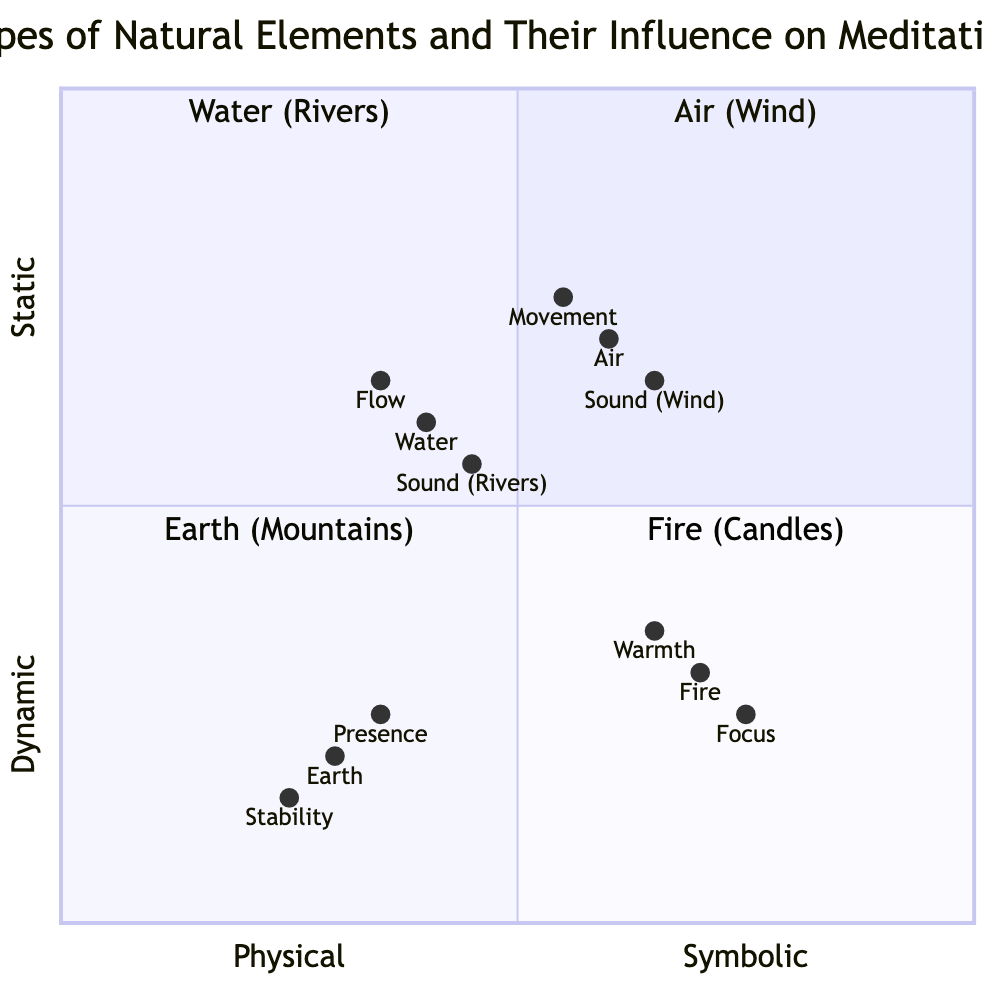What influence does "Water (Rivers)" have on meditation? According to the quadrant chart, "Water (Rivers)" influences meditation by calming the mind and reducing anxiety, creating a rhythmic focus point through sound, and symbolizes the flow of life and adaptability.
Answer: Calms the mind and reduces anxiety Which element symbolizes strength, stability, and stillness? In the chart, "Earth (Mountains)" is associated with strength, stability, and stillness, which is indicated in the symbolism provided in its quadrant.
Answer: Earth (Mountains) Compare the focus influences of "Air (Wind)" and "Fire (Candles)". "Air (Wind)" promotes movement and a sense of freedom, while "Fire (Candles)" offers a single point of concentration to aid in meditation. Here, "Fire (Candles)" provides a more direct focus compared to the freedom aspect of "Air (Wind)".
Answer: Fire (Candles) What is the position of "Air (Wind)" in terms of dynamism and symbolism? "Air (Wind)" is positioned towards the dynamic side with coordinates [0.6, 0.7], which indicates it is more dynamic compared to the other elements, emphasizing its flowing nature and symbolic representation of impermanence.
Answer: Dynamic How does the warmth of "Fire (Candles)" contribute to meditation? The warmth created by "Fire (Candles)" provides a comforting and inviting atmosphere for meditation, aligning with its influence on creating a serene environment that aids the meditative experience.
Answer: Creates a comforting atmosphere What is the significance of movement associated with "Air (Wind)"? The movement of "Air (Wind)" promotes a sense of freedom and the release of mental constraints, which aligns with the dynamic nature represented in its quadrant and emphasizes the connection with meditation.
Answer: Promotes freedom Which element has the lowest stability score? Referring to the chart’s stability values, "Earth (Mountains)" has the lowest stability score of 0.15, indicating it is perceived as the least stable in the context of the other elements in terms of meditation influence.
Answer: 0.15 Which element has the highest focus value? Within the values presented in the chart, "Fire (Candles)" has the highest focus value of 0.75, emphasizing its role in meditation as a pivotal point of concentration.
Answer: 0.75 Does "Water (Rivers)" or "Air (Wind)" have a higher sound influence score? Checking the scores, "Water (Rivers)" has a sound influence score of 0.55, while "Air (Wind)" has a sound score of 0.65, thus indicating that "Air (Wind)" has a higher sound influence in meditation compared to "Water (Rivers)".
Answer: Air (Wind) 